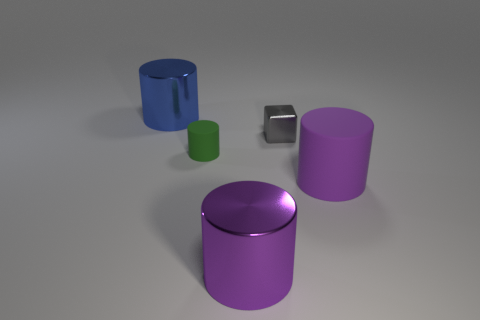The big rubber cylinder is what color?
Offer a very short reply. Purple. How many other things are the same color as the small cylinder?
Provide a short and direct response. 0. There is a big purple matte thing; are there any big things left of it?
Your answer should be compact. Yes. The large metal object that is in front of the large thing that is left of the big metallic thing that is in front of the big blue metal cylinder is what color?
Keep it short and to the point. Purple. How many shiny things are behind the small green matte object and to the left of the small gray block?
Your response must be concise. 1. How many blocks are purple rubber things or tiny gray things?
Provide a short and direct response. 1. Are any blue metal spheres visible?
Provide a short and direct response. No. How many other objects are the same material as the tiny gray thing?
Make the answer very short. 2. There is a blue cylinder that is the same size as the purple shiny cylinder; what is its material?
Your answer should be compact. Metal. There is a large thing behind the green thing; does it have the same shape as the purple matte thing?
Your answer should be very brief. Yes. 